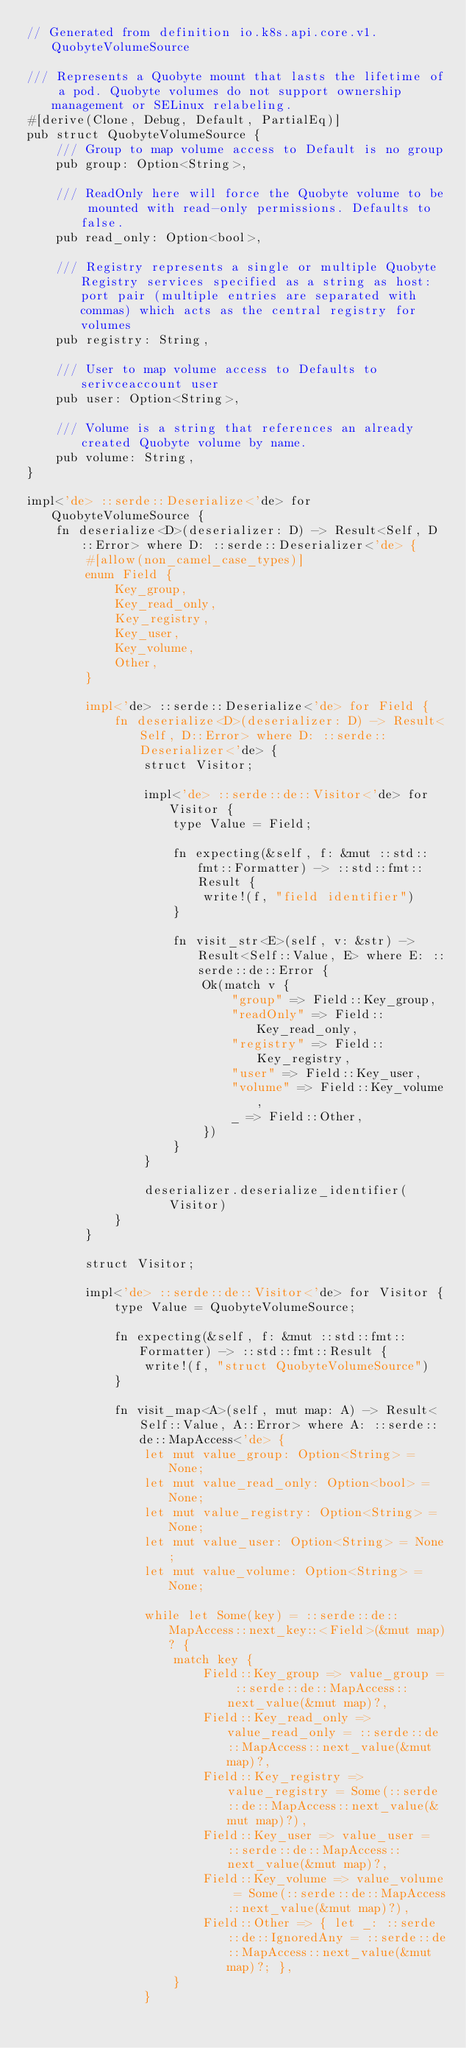Convert code to text. <code><loc_0><loc_0><loc_500><loc_500><_Rust_>// Generated from definition io.k8s.api.core.v1.QuobyteVolumeSource

/// Represents a Quobyte mount that lasts the lifetime of a pod. Quobyte volumes do not support ownership management or SELinux relabeling.
#[derive(Clone, Debug, Default, PartialEq)]
pub struct QuobyteVolumeSource {
    /// Group to map volume access to Default is no group
    pub group: Option<String>,

    /// ReadOnly here will force the Quobyte volume to be mounted with read-only permissions. Defaults to false.
    pub read_only: Option<bool>,

    /// Registry represents a single or multiple Quobyte Registry services specified as a string as host:port pair (multiple entries are separated with commas) which acts as the central registry for volumes
    pub registry: String,

    /// User to map volume access to Defaults to serivceaccount user
    pub user: Option<String>,

    /// Volume is a string that references an already created Quobyte volume by name.
    pub volume: String,
}

impl<'de> ::serde::Deserialize<'de> for QuobyteVolumeSource {
    fn deserialize<D>(deserializer: D) -> Result<Self, D::Error> where D: ::serde::Deserializer<'de> {
        #[allow(non_camel_case_types)]
        enum Field {
            Key_group,
            Key_read_only,
            Key_registry,
            Key_user,
            Key_volume,
            Other,
        }

        impl<'de> ::serde::Deserialize<'de> for Field {
            fn deserialize<D>(deserializer: D) -> Result<Self, D::Error> where D: ::serde::Deserializer<'de> {
                struct Visitor;

                impl<'de> ::serde::de::Visitor<'de> for Visitor {
                    type Value = Field;

                    fn expecting(&self, f: &mut ::std::fmt::Formatter) -> ::std::fmt::Result {
                        write!(f, "field identifier")
                    }

                    fn visit_str<E>(self, v: &str) -> Result<Self::Value, E> where E: ::serde::de::Error {
                        Ok(match v {
                            "group" => Field::Key_group,
                            "readOnly" => Field::Key_read_only,
                            "registry" => Field::Key_registry,
                            "user" => Field::Key_user,
                            "volume" => Field::Key_volume,
                            _ => Field::Other,
                        })
                    }
                }

                deserializer.deserialize_identifier(Visitor)
            }
        }

        struct Visitor;

        impl<'de> ::serde::de::Visitor<'de> for Visitor {
            type Value = QuobyteVolumeSource;

            fn expecting(&self, f: &mut ::std::fmt::Formatter) -> ::std::fmt::Result {
                write!(f, "struct QuobyteVolumeSource")
            }

            fn visit_map<A>(self, mut map: A) -> Result<Self::Value, A::Error> where A: ::serde::de::MapAccess<'de> {
                let mut value_group: Option<String> = None;
                let mut value_read_only: Option<bool> = None;
                let mut value_registry: Option<String> = None;
                let mut value_user: Option<String> = None;
                let mut value_volume: Option<String> = None;

                while let Some(key) = ::serde::de::MapAccess::next_key::<Field>(&mut map)? {
                    match key {
                        Field::Key_group => value_group = ::serde::de::MapAccess::next_value(&mut map)?,
                        Field::Key_read_only => value_read_only = ::serde::de::MapAccess::next_value(&mut map)?,
                        Field::Key_registry => value_registry = Some(::serde::de::MapAccess::next_value(&mut map)?),
                        Field::Key_user => value_user = ::serde::de::MapAccess::next_value(&mut map)?,
                        Field::Key_volume => value_volume = Some(::serde::de::MapAccess::next_value(&mut map)?),
                        Field::Other => { let _: ::serde::de::IgnoredAny = ::serde::de::MapAccess::next_value(&mut map)?; },
                    }
                }
</code> 